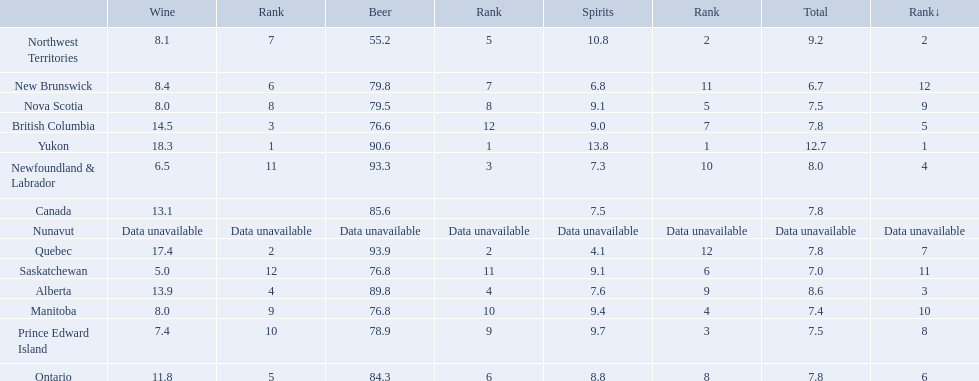What is the first ranked alcoholic beverage in canada Yukon. How many litters is consumed a year? 12.7. Where do people consume the highest average of spirits per year? Yukon. How many liters on average do people here drink per year of spirits? 12.7. Which country ranks #1 in alcoholic beverage consumption? Yukon. Of that country, how many total liters of spirits do they consume? 12.7. 